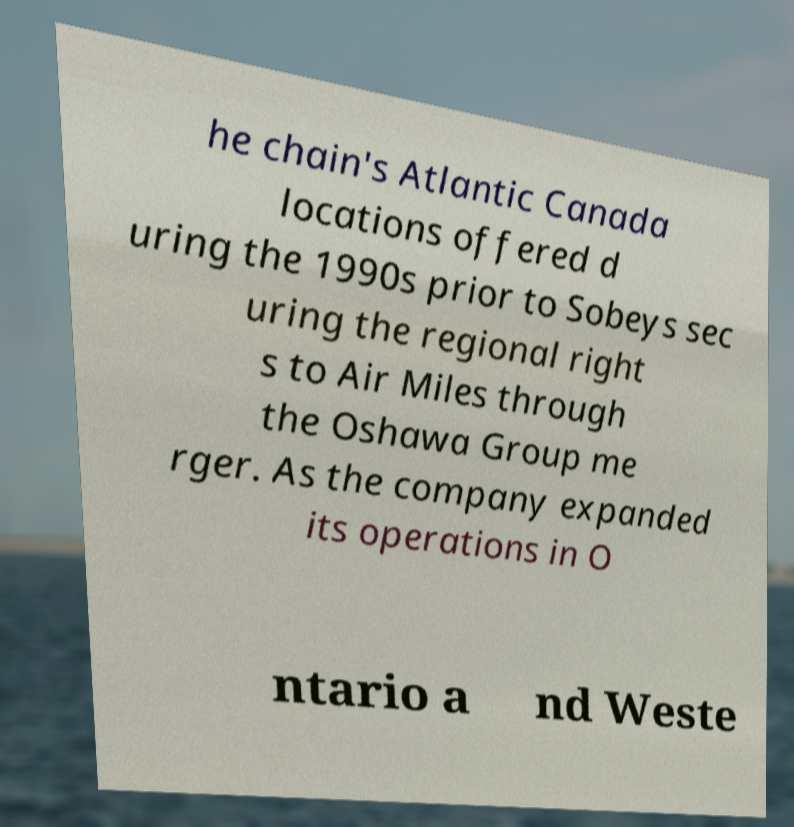Can you read and provide the text displayed in the image?This photo seems to have some interesting text. Can you extract and type it out for me? he chain's Atlantic Canada locations offered d uring the 1990s prior to Sobeys sec uring the regional right s to Air Miles through the Oshawa Group me rger. As the company expanded its operations in O ntario a nd Weste 